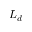<formula> <loc_0><loc_0><loc_500><loc_500>L _ { d }</formula> 